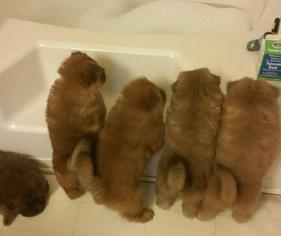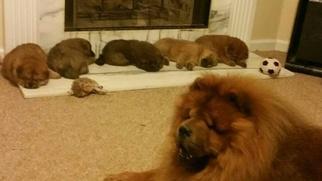The first image is the image on the left, the second image is the image on the right. For the images displayed, is the sentence "Each of the images depicts a single chow dog." factually correct? Answer yes or no. No. 